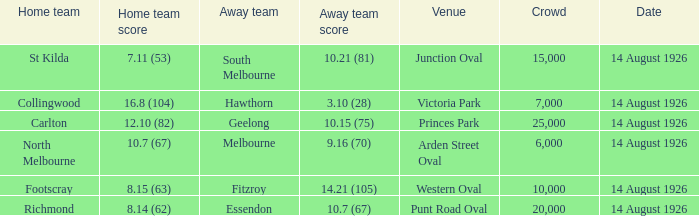Could you help me parse every detail presented in this table? {'header': ['Home team', 'Home team score', 'Away team', 'Away team score', 'Venue', 'Crowd', 'Date'], 'rows': [['St Kilda', '7.11 (53)', 'South Melbourne', '10.21 (81)', 'Junction Oval', '15,000', '14 August 1926'], ['Collingwood', '16.8 (104)', 'Hawthorn', '3.10 (28)', 'Victoria Park', '7,000', '14 August 1926'], ['Carlton', '12.10 (82)', 'Geelong', '10.15 (75)', 'Princes Park', '25,000', '14 August 1926'], ['North Melbourne', '10.7 (67)', 'Melbourne', '9.16 (70)', 'Arden Street Oval', '6,000', '14 August 1926'], ['Footscray', '8.15 (63)', 'Fitzroy', '14.21 (105)', 'Western Oval', '10,000', '14 August 1926'], ['Richmond', '8.14 (62)', 'Essendon', '10.7 (67)', 'Punt Road Oval', '20,000', '14 August 1926']]} What is the total number of spectators who attended north melbourne's home games? 6000.0. 